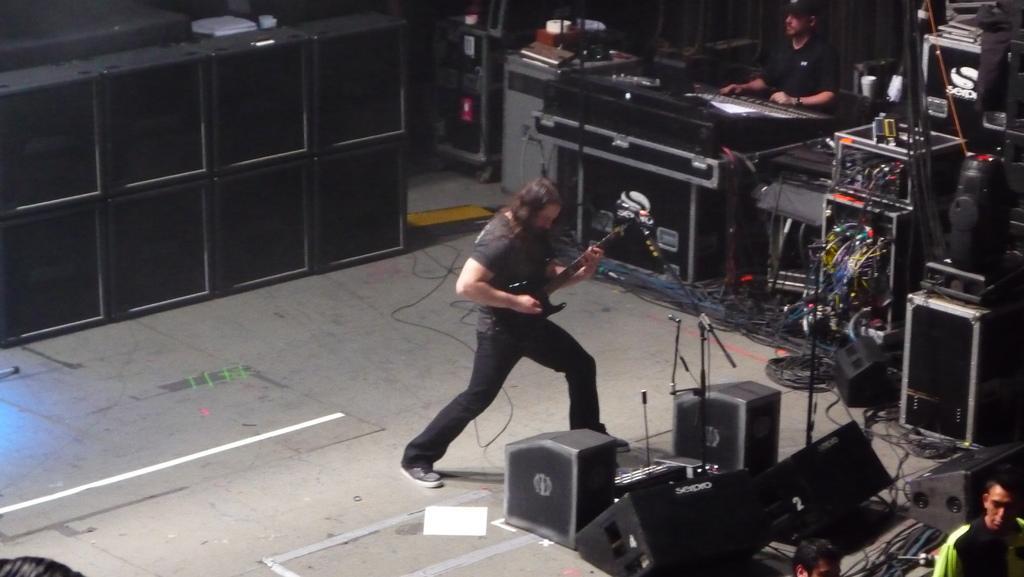In one or two sentences, can you explain what this image depicts? In the image there is a man in black dress playing guitar with speakers in front of him, on the right side there is another man operating amplifier with many musical instruments beside him, there are speakers in the back. 